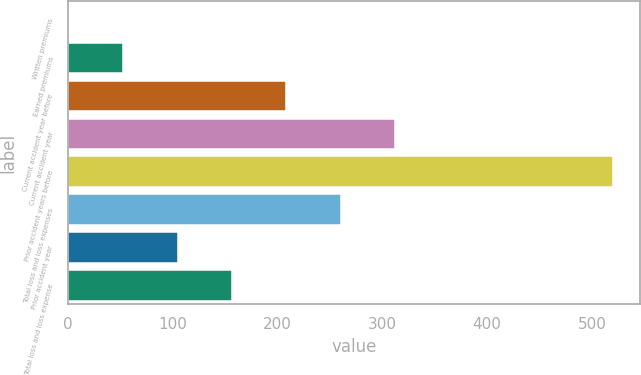Convert chart. <chart><loc_0><loc_0><loc_500><loc_500><bar_chart><fcel>Written premiums<fcel>Earned premiums<fcel>Current accident year before<fcel>Current accident year<fcel>Prior accident years before<fcel>Total loss and loss expenses<fcel>Prior accident year<fcel>Total loss and loss expense<nl><fcel>1.1<fcel>52.96<fcel>208.54<fcel>312.26<fcel>519.7<fcel>260.4<fcel>104.82<fcel>156.68<nl></chart> 